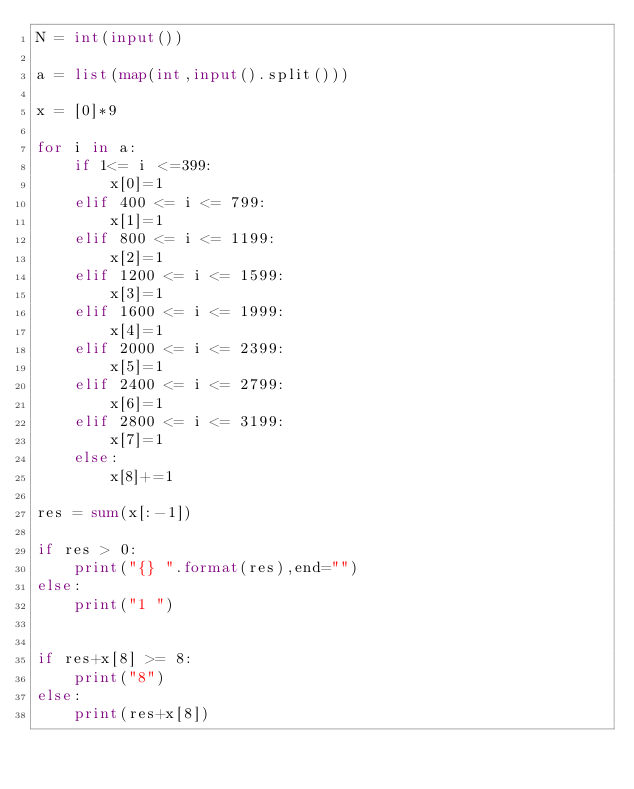Convert code to text. <code><loc_0><loc_0><loc_500><loc_500><_Python_>N = int(input())

a = list(map(int,input().split()))

x = [0]*9

for i in a:
    if 1<= i <=399:
        x[0]=1
    elif 400 <= i <= 799:
        x[1]=1
    elif 800 <= i <= 1199:
        x[2]=1
    elif 1200 <= i <= 1599:
        x[3]=1
    elif 1600 <= i <= 1999:
        x[4]=1
    elif 2000 <= i <= 2399:
        x[5]=1
    elif 2400 <= i <= 2799:
        x[6]=1
    elif 2800 <= i <= 3199:
        x[7]=1
    else:
        x[8]+=1

res = sum(x[:-1])

if res > 0:
    print("{} ".format(res),end="")
else:
    print("1 ")


if res+x[8] >= 8:
    print("8")
else:
    print(res+x[8])
</code> 